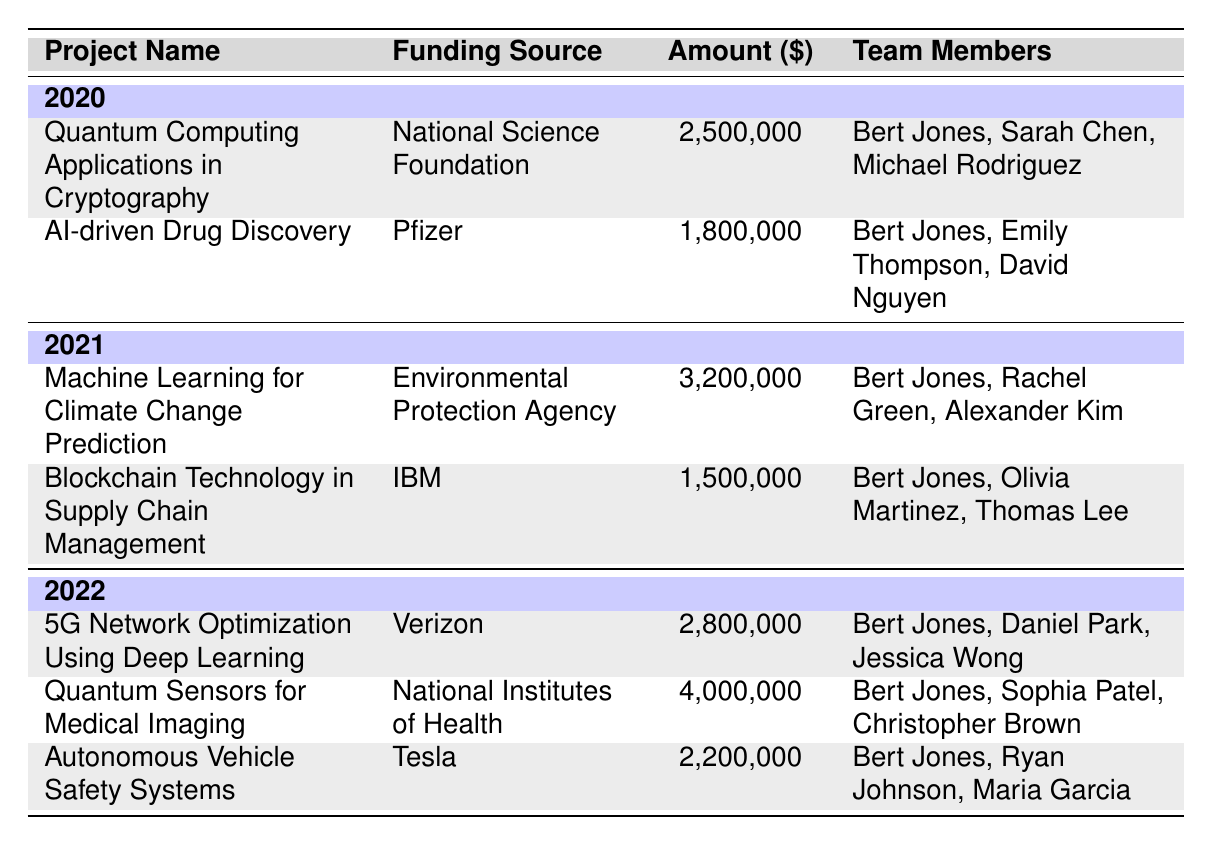What is the total funding secured in 2021? In 2021, there are two projects listed: "Machine Learning for Climate Change Prediction" with funding of $3,200,000 and "Blockchain Technology in Supply Chain Management" with funding of $1,500,000. Adding these amounts gives $3,200,000 + $1,500,000 = $4,700,000.
Answer: 4,700,000 Which project received the highest funding and what was the amount? Reviewing the table, the project "Quantum Sensors for Medical Imaging" received the highest funding of $4,000,000 in 2022.
Answer: Quantum Sensors for Medical Imaging, 4,000,000 Did Bert Jones lead any projects in 2022? Looking at the list of projects in 2022, Bert Jones is listed as a team member in all three projects: "5G Network Optimization Using Deep Learning," "Quantum Sensors for Medical Imaging," and "Autonomous Vehicle Safety Systems." Therefore, yes, he did lead projects in 2022.
Answer: Yes What is the average funding amount for projects in 2020? In 2020, there are two projects: "Quantum Computing Applications in Cryptography" ($2,500,000) and "AI-driven Drug Discovery" ($1,800,000). To find the average, add the amounts: $2,500,000 + $1,800,000 = $4,300,000, and then divide by 2 (the number of projects), resulting in an average of $4,300,000 / 2 = $2,150,000.
Answer: 2,150,000 How many projects received funding from the National Science Foundation? The table lists one project for the National Science Foundation in 2020: "Quantum Computing Applications in Cryptography." Thus, the total is one project.
Answer: 1 What is the total funding amount secured by Bert Jones in 2020 and 2021 combined? In 2020, Bert Jones was involved in two projects with a total funding of $4,300,000, and in 2021, he was involved in two projects totaling $4,700,000. Adding both totals gives $4,300,000 + $4,700,000 = $9,000,000.
Answer: 9,000,000 Which funding source contributed the most to Bert Jones's projects over the years? The table shows that the National Institutes of Health contributed $4,000,000 for "Quantum Sensors for Medical Imaging" in 2022, which is the highest single amount compared to other funding sources.
Answer: National Institutes of Health Count the number of distinct team members listed across all the projects. From the table, the unique team members are: Bert Jones, Sarah Chen, Michael Rodriguez, Emily Thompson, David Nguyen, Rachel Green, Alexander Kim, Olivia Martinez, Thomas Lee, Daniel Park, Jessica Wong, Sophia Patel, Christopher Brown, Ryan Johnson, and Maria Garcia. This gives a total of 14 distinct members.
Answer: 14 Which year had the least total funding secured across all its projects? Comparing the total funding for each year: 2020 ($4,300,000), 2021 ($4,700,000), 2022 ($9,000,000), we see that 2020 had the least amount.
Answer: 2020 Is there a project in 2021 where Bert Jones was the only team member listed? In 2021, all projects listed had at least three team members including Bert Jones, hence there is no project where he is the only member listed.
Answer: No 